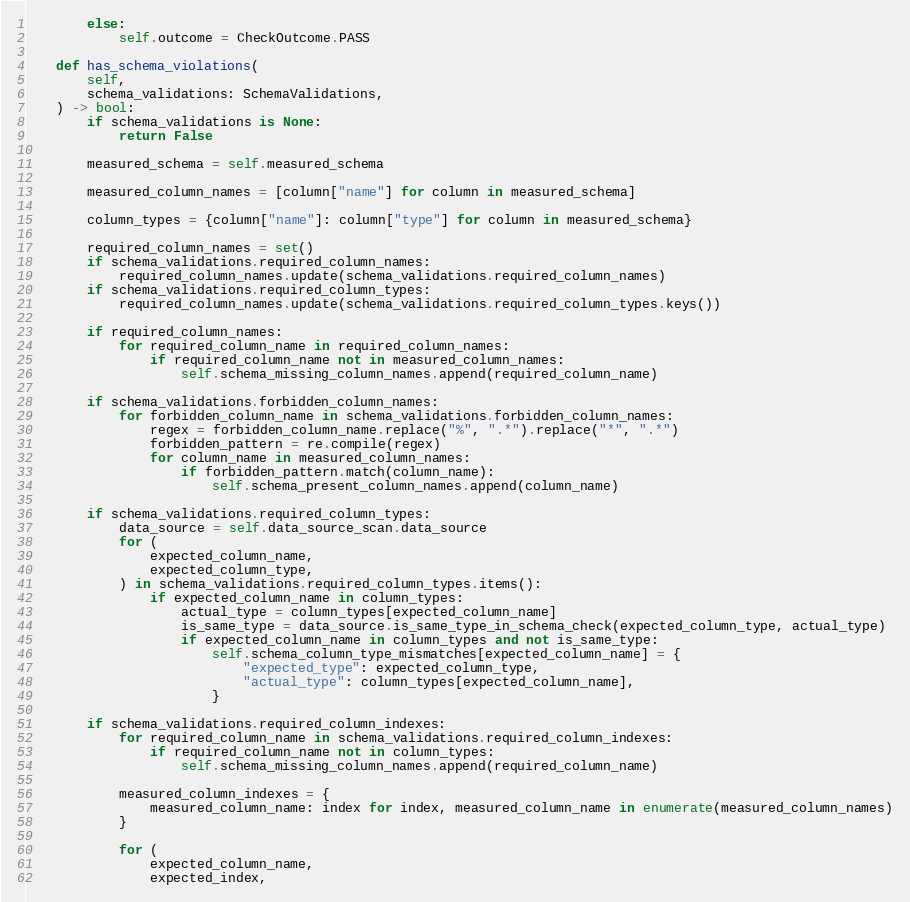Convert code to text. <code><loc_0><loc_0><loc_500><loc_500><_Python_>        else:
            self.outcome = CheckOutcome.PASS

    def has_schema_violations(
        self,
        schema_validations: SchemaValidations,
    ) -> bool:
        if schema_validations is None:
            return False

        measured_schema = self.measured_schema

        measured_column_names = [column["name"] for column in measured_schema]

        column_types = {column["name"]: column["type"] for column in measured_schema}

        required_column_names = set()
        if schema_validations.required_column_names:
            required_column_names.update(schema_validations.required_column_names)
        if schema_validations.required_column_types:
            required_column_names.update(schema_validations.required_column_types.keys())

        if required_column_names:
            for required_column_name in required_column_names:
                if required_column_name not in measured_column_names:
                    self.schema_missing_column_names.append(required_column_name)

        if schema_validations.forbidden_column_names:
            for forbidden_column_name in schema_validations.forbidden_column_names:
                regex = forbidden_column_name.replace("%", ".*").replace("*", ".*")
                forbidden_pattern = re.compile(regex)
                for column_name in measured_column_names:
                    if forbidden_pattern.match(column_name):
                        self.schema_present_column_names.append(column_name)

        if schema_validations.required_column_types:
            data_source = self.data_source_scan.data_source
            for (
                expected_column_name,
                expected_column_type,
            ) in schema_validations.required_column_types.items():
                if expected_column_name in column_types:
                    actual_type = column_types[expected_column_name]
                    is_same_type = data_source.is_same_type_in_schema_check(expected_column_type, actual_type)
                    if expected_column_name in column_types and not is_same_type:
                        self.schema_column_type_mismatches[expected_column_name] = {
                            "expected_type": expected_column_type,
                            "actual_type": column_types[expected_column_name],
                        }

        if schema_validations.required_column_indexes:
            for required_column_name in schema_validations.required_column_indexes:
                if required_column_name not in column_types:
                    self.schema_missing_column_names.append(required_column_name)

            measured_column_indexes = {
                measured_column_name: index for index, measured_column_name in enumerate(measured_column_names)
            }

            for (
                expected_column_name,
                expected_index,</code> 